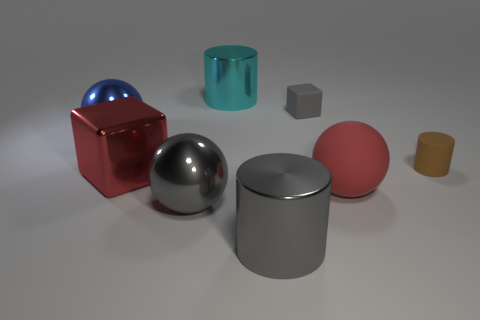Subtract all big metal cylinders. How many cylinders are left? 1 Add 1 yellow matte spheres. How many objects exist? 9 Subtract all gray blocks. How many blocks are left? 1 Subtract all cylinders. How many objects are left? 5 Subtract 2 blocks. How many blocks are left? 0 Subtract all gray blocks. Subtract all brown balls. How many blocks are left? 1 Subtract all green balls. How many blue blocks are left? 0 Subtract all large yellow metal balls. Subtract all big gray cylinders. How many objects are left? 7 Add 4 red cubes. How many red cubes are left? 5 Add 1 big gray rubber cylinders. How many big gray rubber cylinders exist? 1 